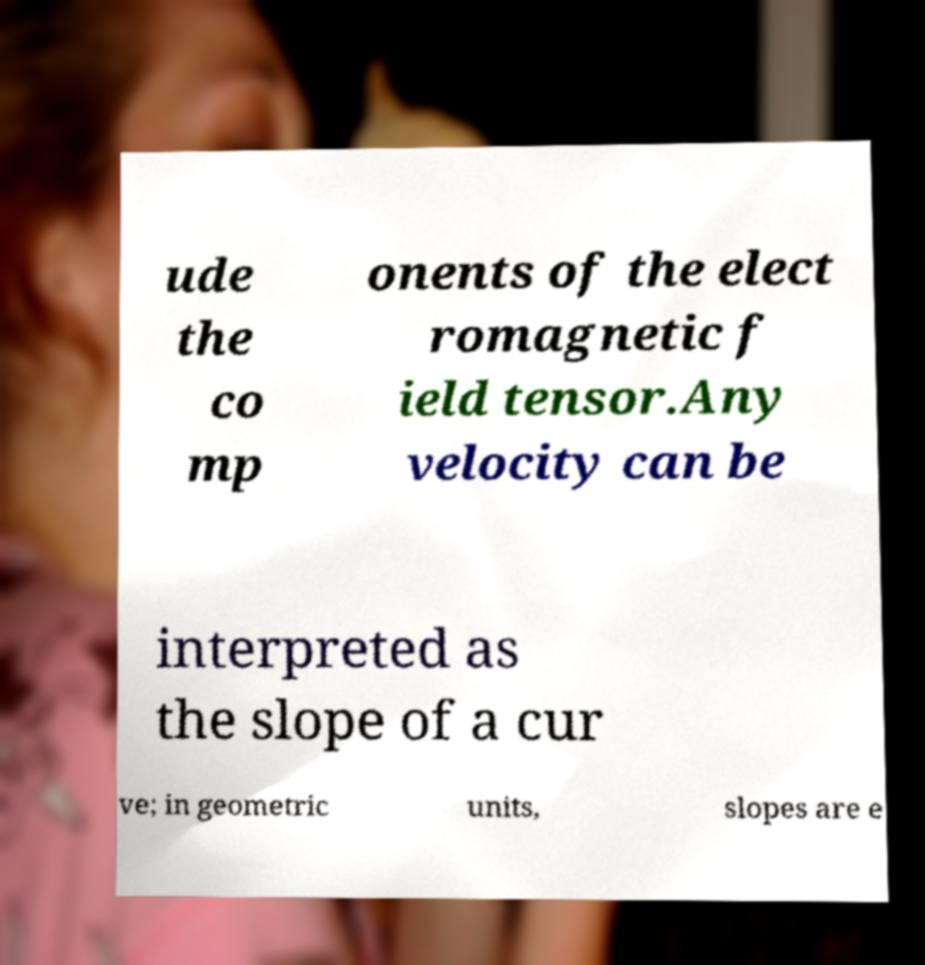For documentation purposes, I need the text within this image transcribed. Could you provide that? ude the co mp onents of the elect romagnetic f ield tensor.Any velocity can be interpreted as the slope of a cur ve; in geometric units, slopes are e 